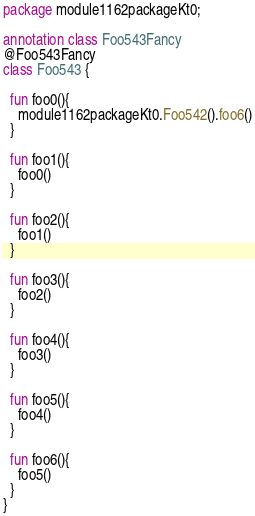Convert code to text. <code><loc_0><loc_0><loc_500><loc_500><_Kotlin_>package module1162packageKt0;

annotation class Foo543Fancy
@Foo543Fancy
class Foo543 {

  fun foo0(){
    module1162packageKt0.Foo542().foo6()
  }

  fun foo1(){
    foo0()
  }

  fun foo2(){
    foo1()
  }

  fun foo3(){
    foo2()
  }

  fun foo4(){
    foo3()
  }

  fun foo5(){
    foo4()
  }

  fun foo6(){
    foo5()
  }
}</code> 